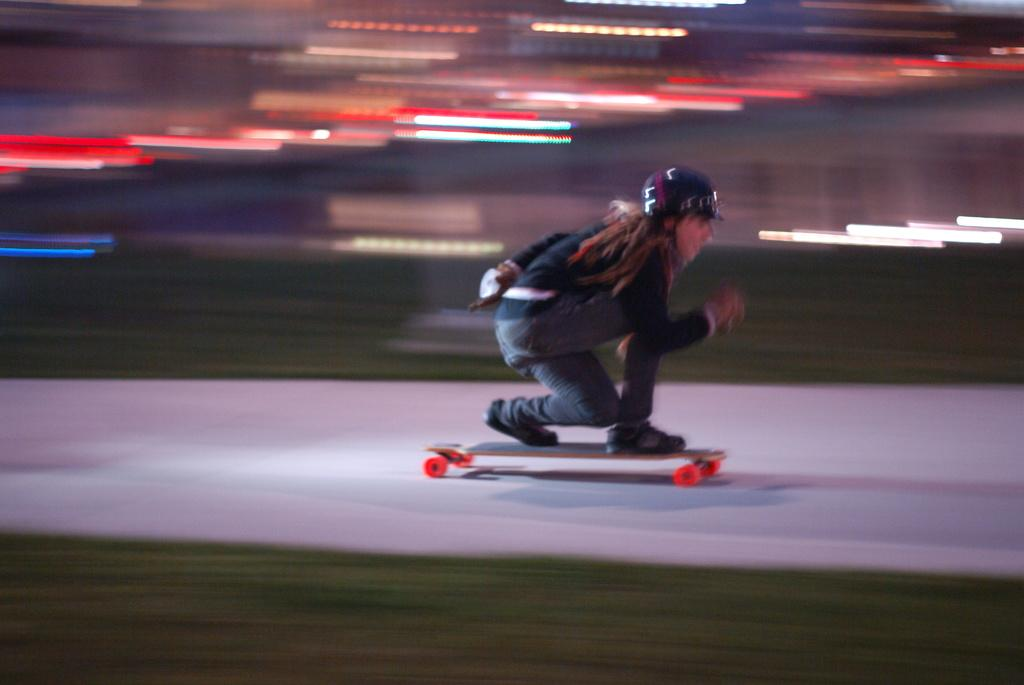What is the main subject of the image? There is a person in the image. What is the person wearing? The person is wearing a dress and a helmet. What is the person standing on? The person is standing on a skateboard. What is the position of the skateboard in the image? The skateboard is placed on the ground. What type of berry can be seen in the person's hand in the image? There is no berry present in the person's hand or anywhere in the image. What songs is the person listening to while skateboarding in the image? There is no information about the person listening to songs or any audio source in the image. 